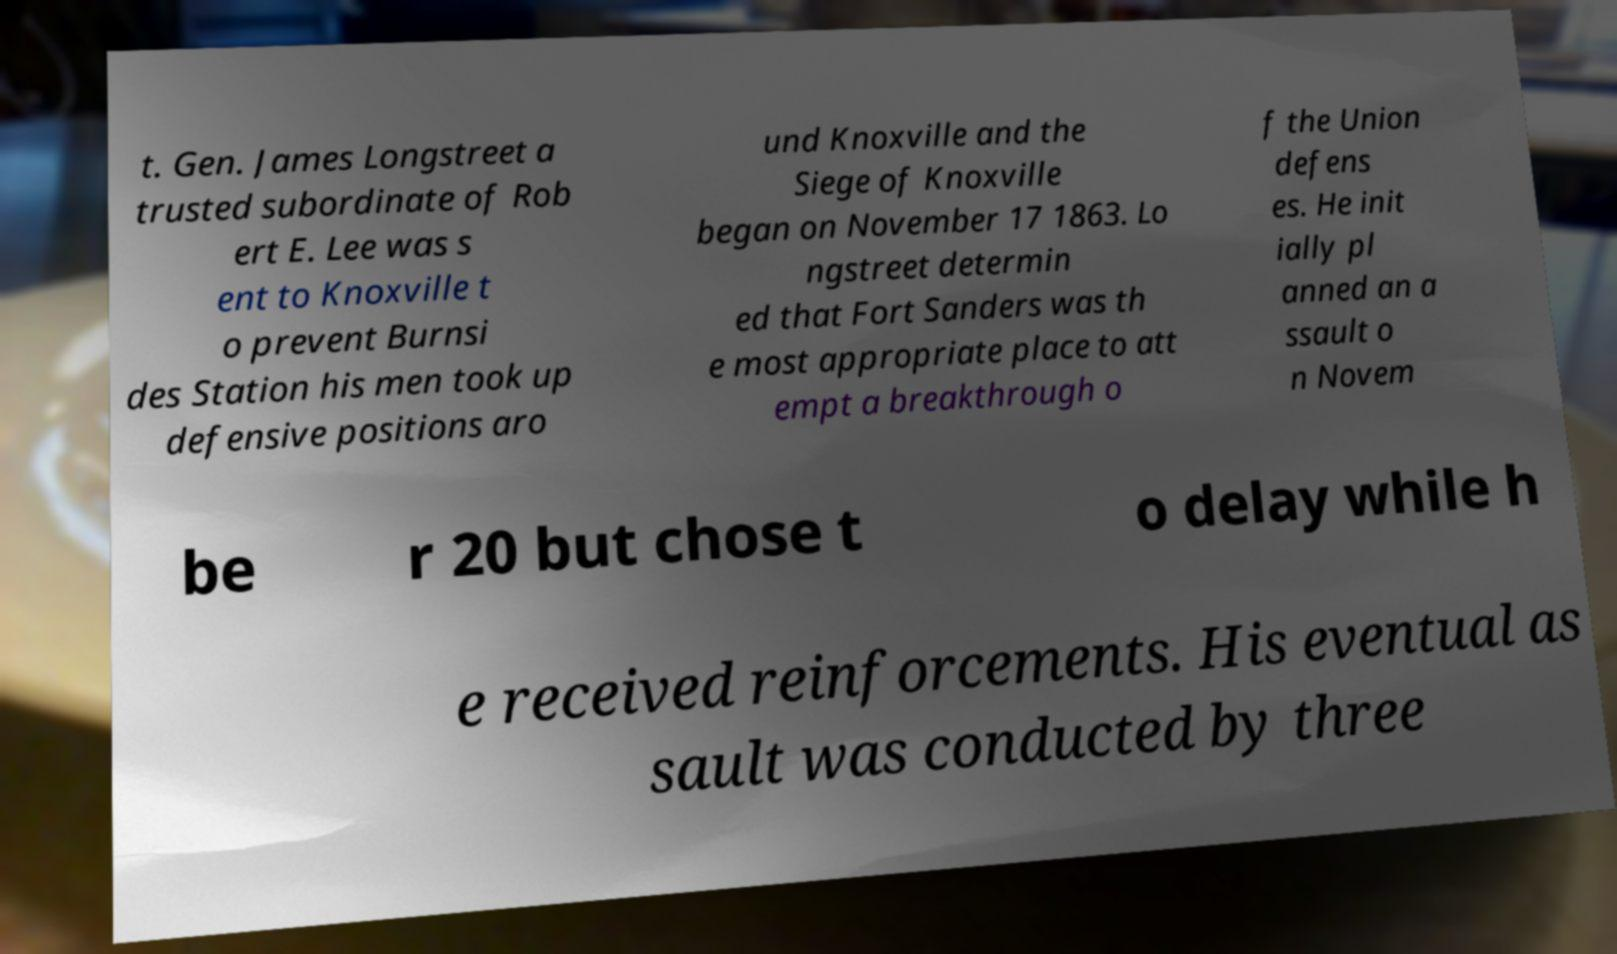There's text embedded in this image that I need extracted. Can you transcribe it verbatim? t. Gen. James Longstreet a trusted subordinate of Rob ert E. Lee was s ent to Knoxville t o prevent Burnsi des Station his men took up defensive positions aro und Knoxville and the Siege of Knoxville began on November 17 1863. Lo ngstreet determin ed that Fort Sanders was th e most appropriate place to att empt a breakthrough o f the Union defens es. He init ially pl anned an a ssault o n Novem be r 20 but chose t o delay while h e received reinforcements. His eventual as sault was conducted by three 